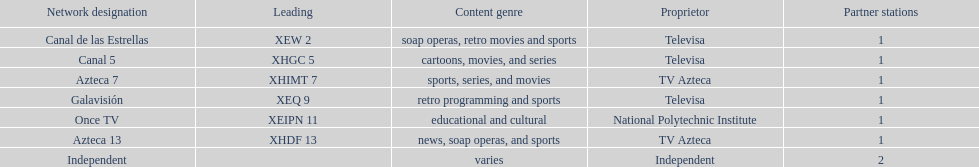What is the difference between the number of affiliates galavision has and the number of affiliates azteca 13 has? 0. 